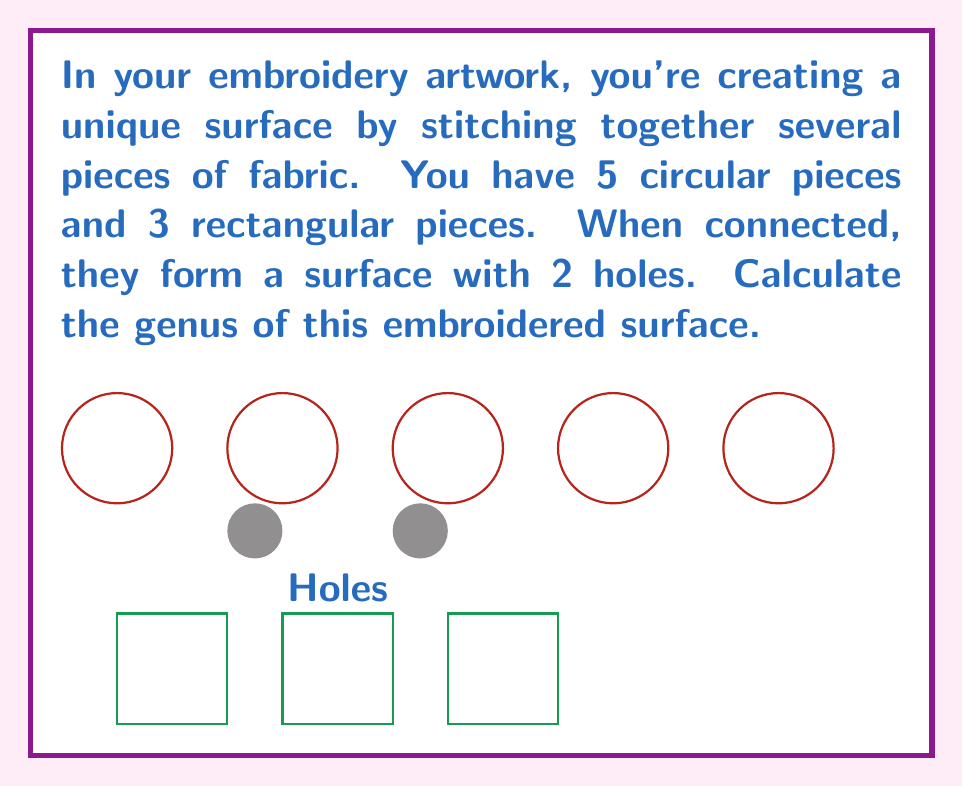Can you answer this question? To determine the genus of the surface created by stitching together these fabric pieces, we need to understand the concept of genus in topology:

1. The genus of a surface is the number of handles or "holes" it has.

2. For a connected, orientable surface, the genus is related to the Euler characteristic $\chi$ by the formula:

   $$\chi = 2 - 2g$$

   where $g$ is the genus.

3. The Euler characteristic is calculated using the formula:

   $$\chi = V - E + F$$

   where $V$ is the number of vertices, $E$ is the number of edges, and $F$ is the number of faces.

4. In this case, we're told that the surface has 2 holes, which directly gives us the genus.

5. We can verify this using the Euler characteristic formula:
   - The surface is made of 8 pieces (5 circles + 3 rectangles), so $F = 8$
   - The number of vertices and edges would depend on how the pieces are stitched together, but we don't need to calculate them.

6. Given that the genus $g = 2$, we can use the formula from step 2:

   $$\chi = 2 - 2g = 2 - 2(2) = -2$$

This confirms that the surface indeed has a genus of 2.
Answer: $g = 2$ 